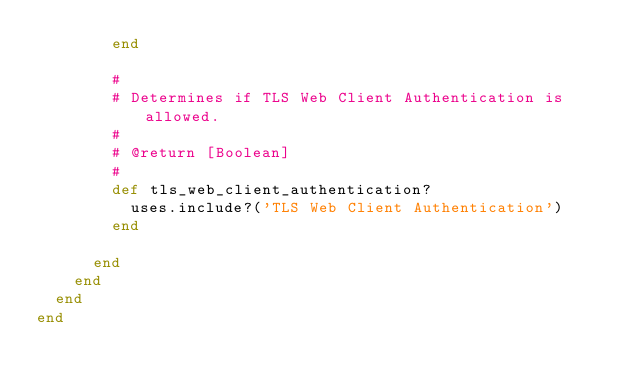Convert code to text. <code><loc_0><loc_0><loc_500><loc_500><_Ruby_>        end

        #
        # Determines if TLS Web Client Authentication is allowed.
        #
        # @return [Boolean]
        #
        def tls_web_client_authentication?
          uses.include?('TLS Web Client Authentication')
        end

      end
    end
  end
end
</code> 